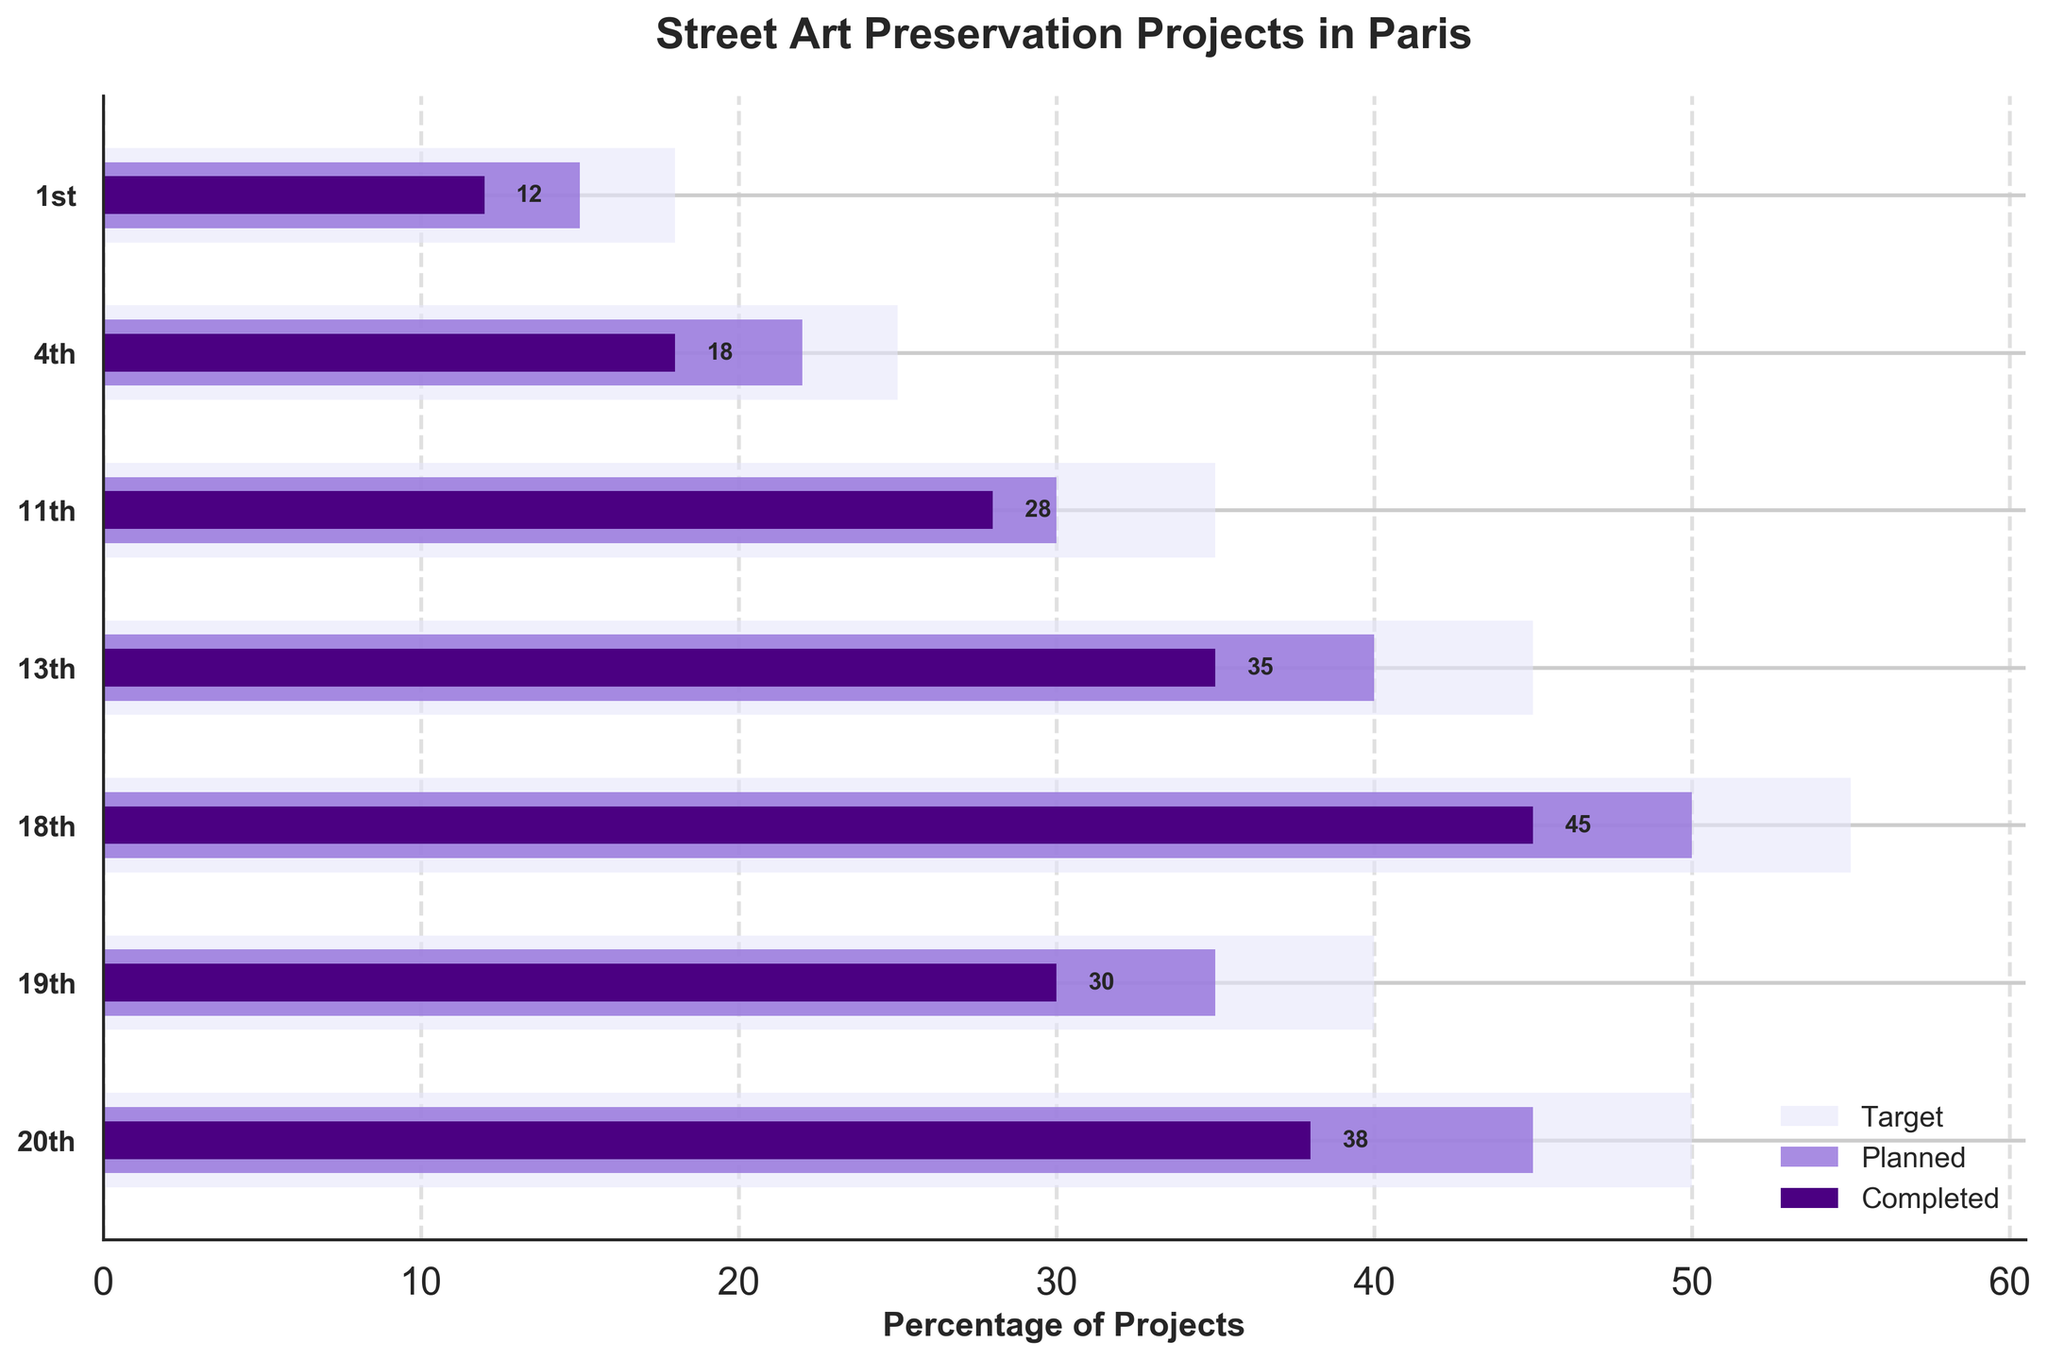Which arrondissement in Paris has the highest target for street art preservation projects? To find the arrondissement with the highest target, look at the length of the background bars (Target values). The longest bar corresponds to the highest target, which in this case is for the 18th arrondissement.
Answer: 18th What is the difference between the planned and completed projects for the 13th arrondissement? Look at the Planned and Completed bars for the 13th arrondissement. The Planned projects are 40, and the Completed projects are 35. The difference is 40 - 35.
Answer: 5 Which arrondissement has the most significant gap between the target and completed projects? To find the arrondissement with the most significant gap, subtract the Completed bars from the Target bars for each arrondissement and compare. The largest difference is seen in the 20th arrondissement with a gap of 50 - 38.
Answer: 20th What is the total number of planned projects across all arrondissements? Sum the Planned values for all arrondissements: 15 + 22 + 30 + 40 + 50 + 35 + 45.
Answer: 237 How does the percentage of completed projects in the 11th arrondissement compare to the target? To calculate the percentage, divide Completed by Target and multiply by 100. For the 11th arrondissement: (28 / 35) * 100 ≈ 80%. Compare this to the other arrondissements to see it is relatively high.
Answer: 80% Which arrondissement has the closest numbers of planned and completed projects? Compare the difference between Planned and Completed projects for each arrondissement. The 11th arrondissement has the closest numbers, with a difference of only 2 projects (30 - 28).
Answer: 11th What is the average target for the arrondissements shown? Sum the Target values and then divide by the number of arrondissements. (18 + 25 + 35 + 45 + 55 + 40 + 50) / 7 ≈ 38.29.
Answer: ~38.29 Is there any arrondissement where the completed projects exceed the planned projects? Scan through the bars to check if any Completed bar is longer than the Planned bar. None of the arrondissements have Completed projects exceeding Planned projects.
Answer: No 